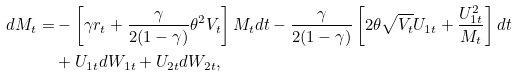<formula> <loc_0><loc_0><loc_500><loc_500>d M _ { t } = & - \left [ \gamma r _ { t } + \frac { \gamma } { 2 ( 1 - \gamma ) } \theta ^ { 2 } V _ { t } \right ] M _ { t } d t - \frac { \gamma } { 2 ( 1 - \gamma ) } \left [ 2 \theta \sqrt { V _ { t } } U _ { 1 t } + \frac { U ^ { 2 } _ { 1 t } } { M _ { t } } \right ] d t \\ & + U _ { 1 t } d W _ { 1 t } + U _ { 2 t } d W _ { 2 t } ,</formula> 